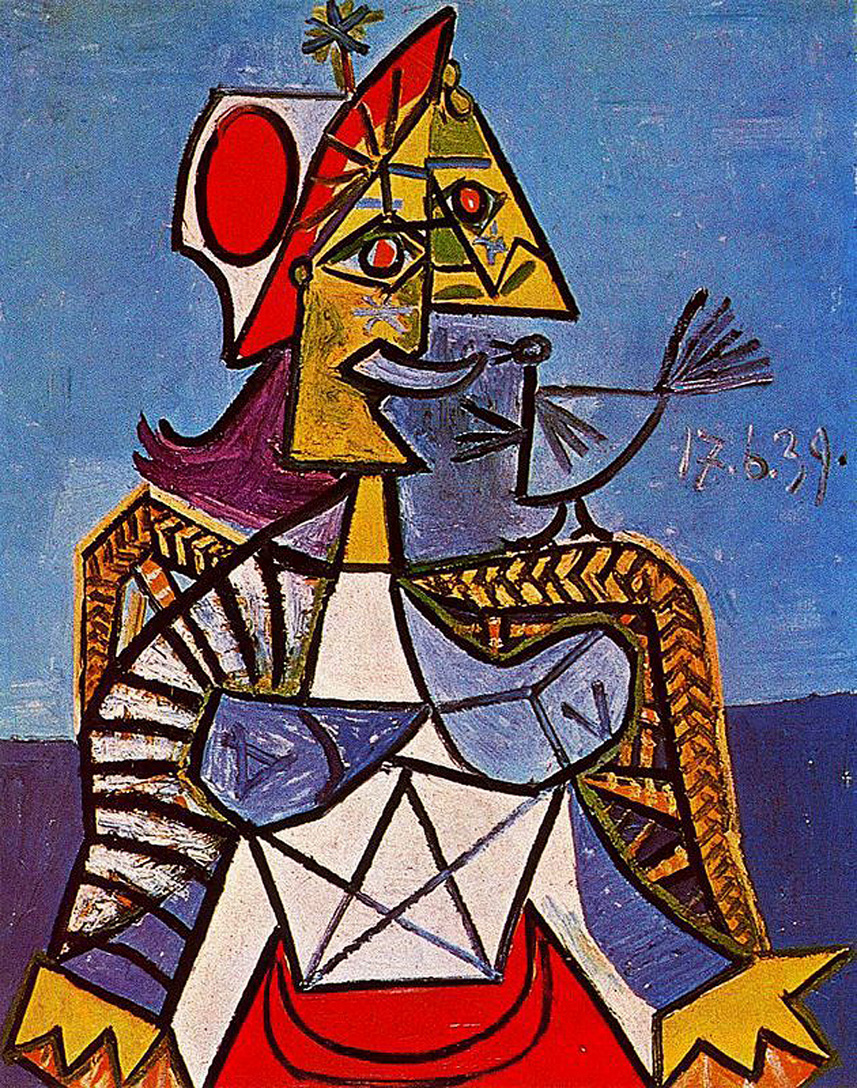Considering the style of this artwork, what might be its historical and cultural significance? This artwork is emblematic of the Cubist movement, which emerged in the early 20th century. Cubism, pioneered by artists such as Pablo Picasso and Georges Braque, represented a radical departure from traditional perspectives by deconstructing subjects into geometric shapes and presenting multiple viewpoints simultaneously. This style challenged conventional norms of representation and sought to capture the essence of subjects in a more abstract, multifaceted manner.

The historical significance of this piece lies in its reflection of the early 20th-century zeitgeist, a time of tremendous change and innovation in art, science, and society. The artwork encapsulates the spirit of experimentation and the breaking of boundaries that characterized the Modernist era. Culturally, Cubism influenced a wide array of disciplines, from architecture to literature, and became a cornerstone of the avant-garde movement. The crowned figure and the bird may symbolize the tension between tradition and modernity, power and freedom, reflecting broader themes of the era's cultural and intellectual landscape. This piece, therefore, invites viewers to explore not just its aesthetic qualities but also its profound historical and cultural contexts. 